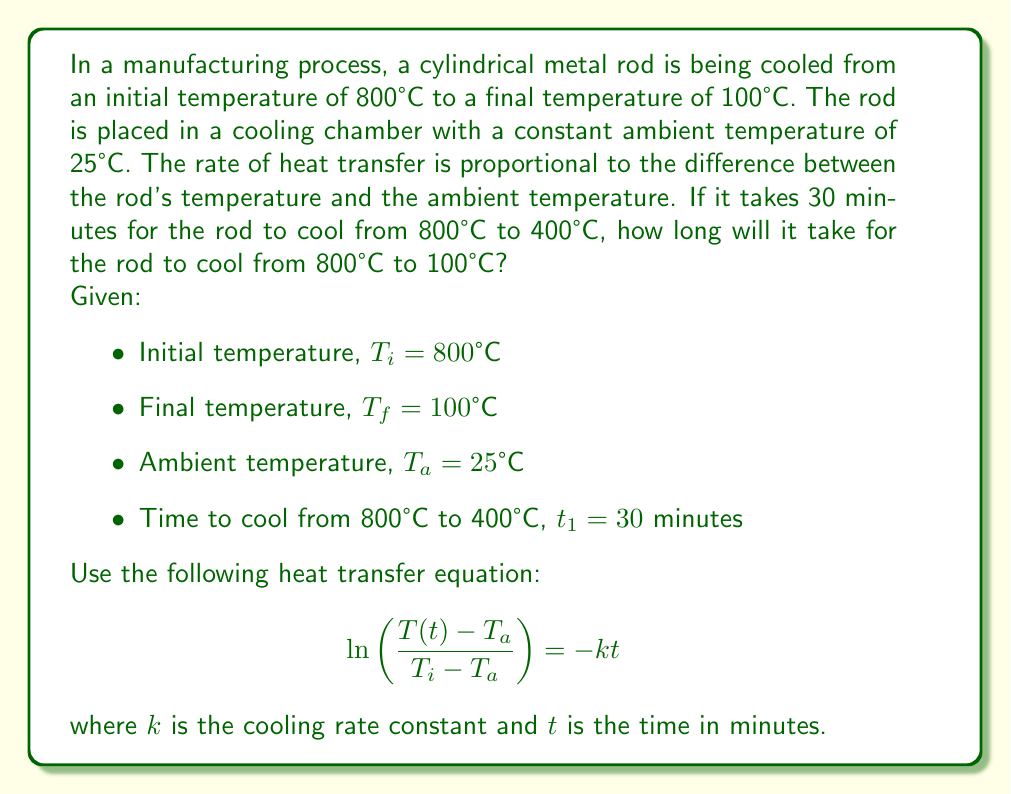Can you answer this question? To solve this problem, we'll follow these steps:

1) First, we need to find the cooling rate constant $k$ using the given information that it takes 30 minutes to cool from 800°C to 400°C.

   Using the heat transfer equation:
   $$ \ln\left(\frac{T(t) - T_a}{T_i - T_a}\right) = -kt $$

   Substituting the known values:
   $$ \ln\left(\frac{400 - 25}{800 - 25}\right) = -k(30) $$

2) Simplify:
   $$ \ln\left(\frac{375}{775}\right) = -30k $$

3) Solve for $k$:
   $$ k = -\frac{1}{30}\ln\left(\frac{375}{775}\right) \approx 0.0256 \text{ min}^{-1} $$

4) Now that we have $k$, we can use the same equation to find the time $t$ it takes to cool from 800°C to 100°C:

   $$ \ln\left(\frac{100 - 25}{800 - 25}\right) = -0.0256t $$

5) Simplify:
   $$ \ln\left(\frac{75}{775}\right) = -0.0256t $$

6) Solve for $t$:
   $$ t = -\frac{1}{0.0256}\ln\left(\frac{75}{775}\right) \approx 82.69 \text{ minutes} $$

Therefore, it will take approximately 82.69 minutes for the rod to cool from 800°C to 100°C.
Answer: $82.69$ minutes 